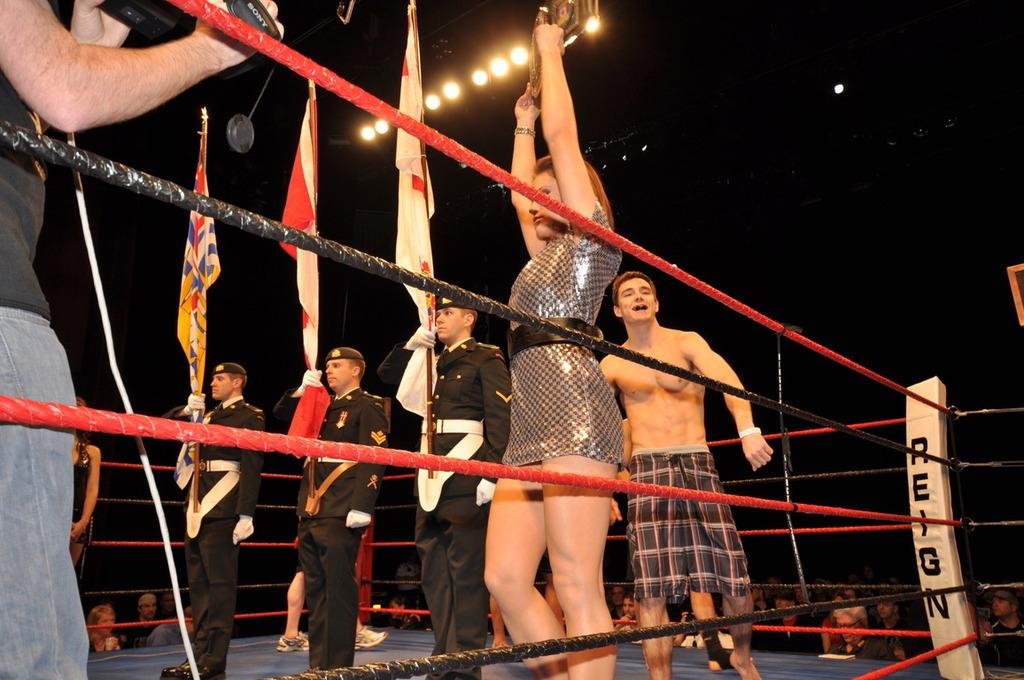Provide a one-sentence caption for the provided image. A group of people stand in a boxing ring with the word Reign. 